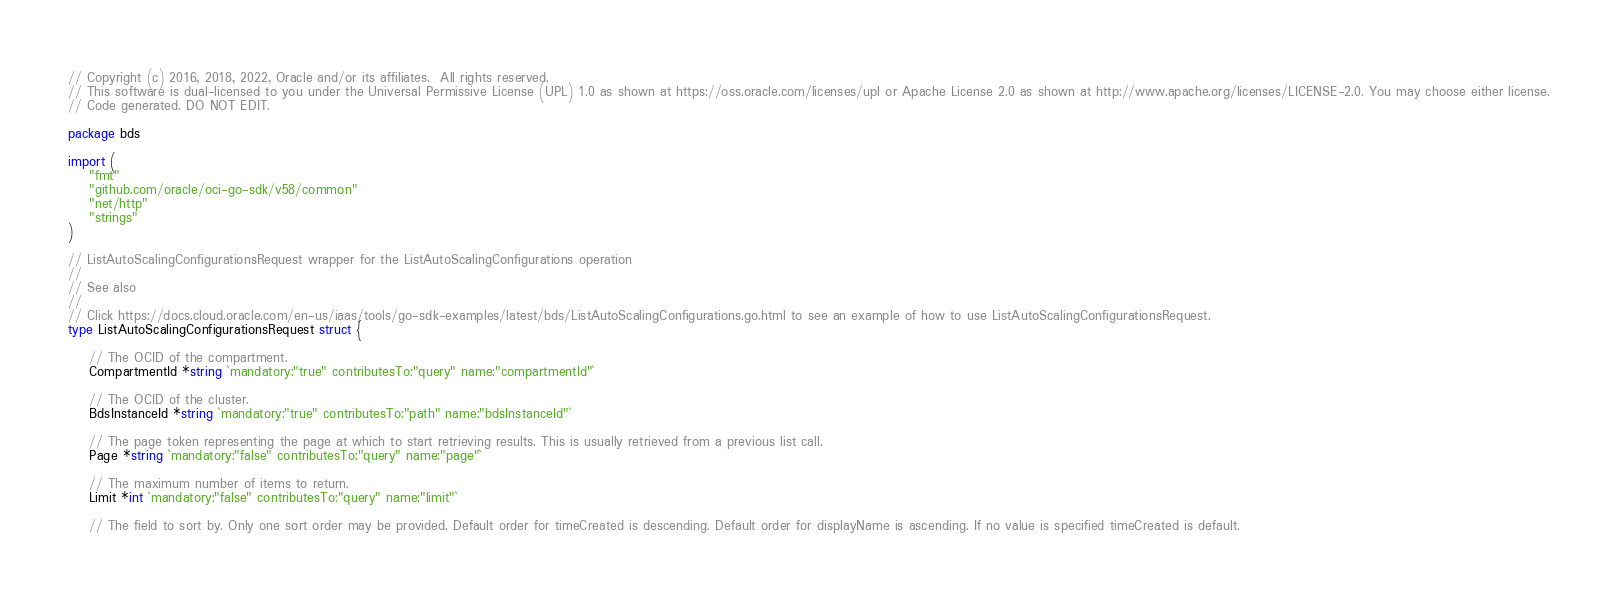<code> <loc_0><loc_0><loc_500><loc_500><_Go_>// Copyright (c) 2016, 2018, 2022, Oracle and/or its affiliates.  All rights reserved.
// This software is dual-licensed to you under the Universal Permissive License (UPL) 1.0 as shown at https://oss.oracle.com/licenses/upl or Apache License 2.0 as shown at http://www.apache.org/licenses/LICENSE-2.0. You may choose either license.
// Code generated. DO NOT EDIT.

package bds

import (
	"fmt"
	"github.com/oracle/oci-go-sdk/v58/common"
	"net/http"
	"strings"
)

// ListAutoScalingConfigurationsRequest wrapper for the ListAutoScalingConfigurations operation
//
// See also
//
// Click https://docs.cloud.oracle.com/en-us/iaas/tools/go-sdk-examples/latest/bds/ListAutoScalingConfigurations.go.html to see an example of how to use ListAutoScalingConfigurationsRequest.
type ListAutoScalingConfigurationsRequest struct {

	// The OCID of the compartment.
	CompartmentId *string `mandatory:"true" contributesTo:"query" name:"compartmentId"`

	// The OCID of the cluster.
	BdsInstanceId *string `mandatory:"true" contributesTo:"path" name:"bdsInstanceId"`

	// The page token representing the page at which to start retrieving results. This is usually retrieved from a previous list call.
	Page *string `mandatory:"false" contributesTo:"query" name:"page"`

	// The maximum number of items to return.
	Limit *int `mandatory:"false" contributesTo:"query" name:"limit"`

	// The field to sort by. Only one sort order may be provided. Default order for timeCreated is descending. Default order for displayName is ascending. If no value is specified timeCreated is default.</code> 